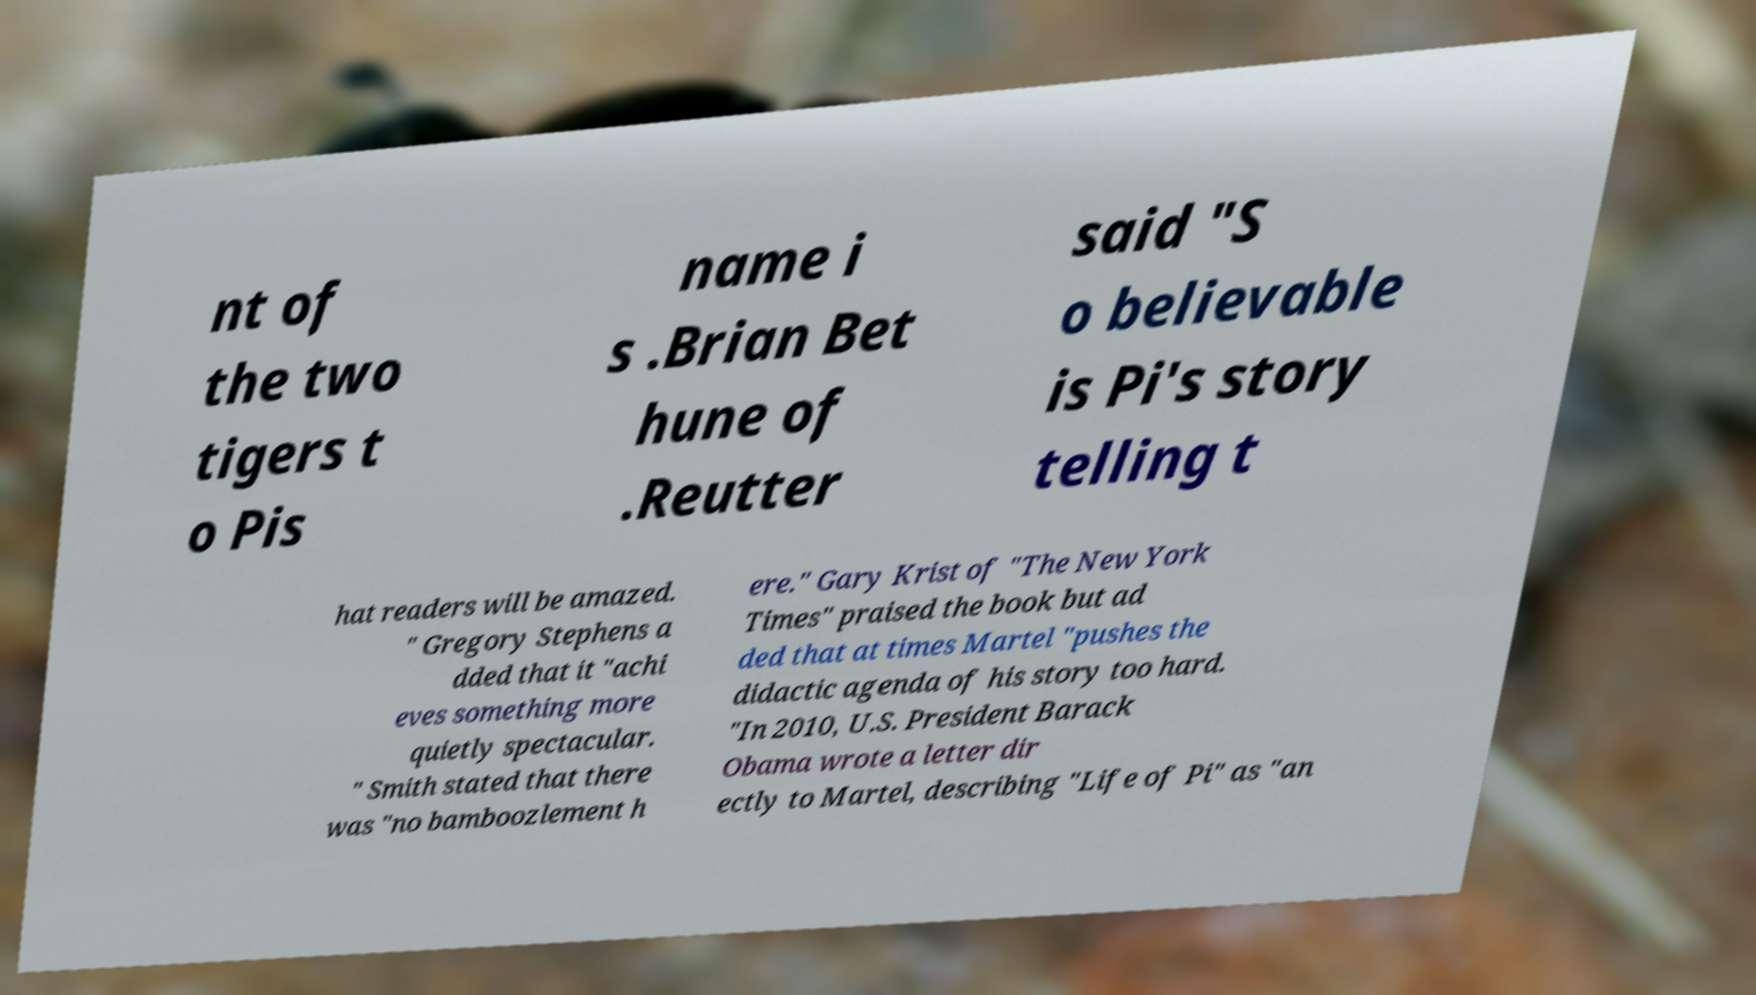There's text embedded in this image that I need extracted. Can you transcribe it verbatim? nt of the two tigers t o Pis name i s .Brian Bet hune of .Reutter said "S o believable is Pi's story telling t hat readers will be amazed. " Gregory Stephens a dded that it "achi eves something more quietly spectacular. " Smith stated that there was "no bamboozlement h ere." Gary Krist of "The New York Times" praised the book but ad ded that at times Martel "pushes the didactic agenda of his story too hard. "In 2010, U.S. President Barack Obama wrote a letter dir ectly to Martel, describing "Life of Pi" as "an 